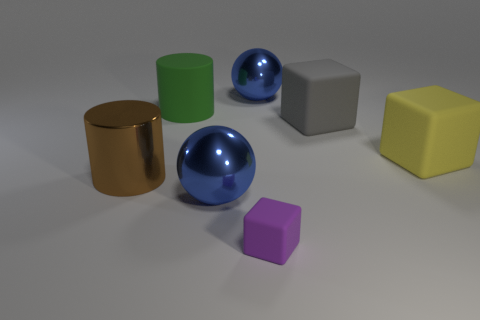How many large gray matte things have the same shape as the small purple object?
Offer a terse response. 1. How many green cylinders are there?
Keep it short and to the point. 1. There is a yellow thing; is it the same shape as the rubber thing that is left of the tiny purple rubber object?
Your answer should be compact. No. What number of objects are big rubber objects or big objects behind the brown shiny cylinder?
Offer a very short reply. 4. There is a large green object that is the same shape as the big brown object; what is it made of?
Provide a short and direct response. Rubber. There is a blue metallic object that is to the left of the purple matte block; is its shape the same as the brown object?
Give a very brief answer. No. Are there any other things that are the same size as the purple block?
Provide a succinct answer. No. Are there fewer blue metallic balls behind the large brown cylinder than big green matte things in front of the small purple matte block?
Keep it short and to the point. No. How many other things are there of the same shape as the big brown thing?
Your response must be concise. 1. How big is the block that is in front of the shiny sphere that is in front of the blue sphere that is to the right of the purple rubber cube?
Ensure brevity in your answer.  Small. 